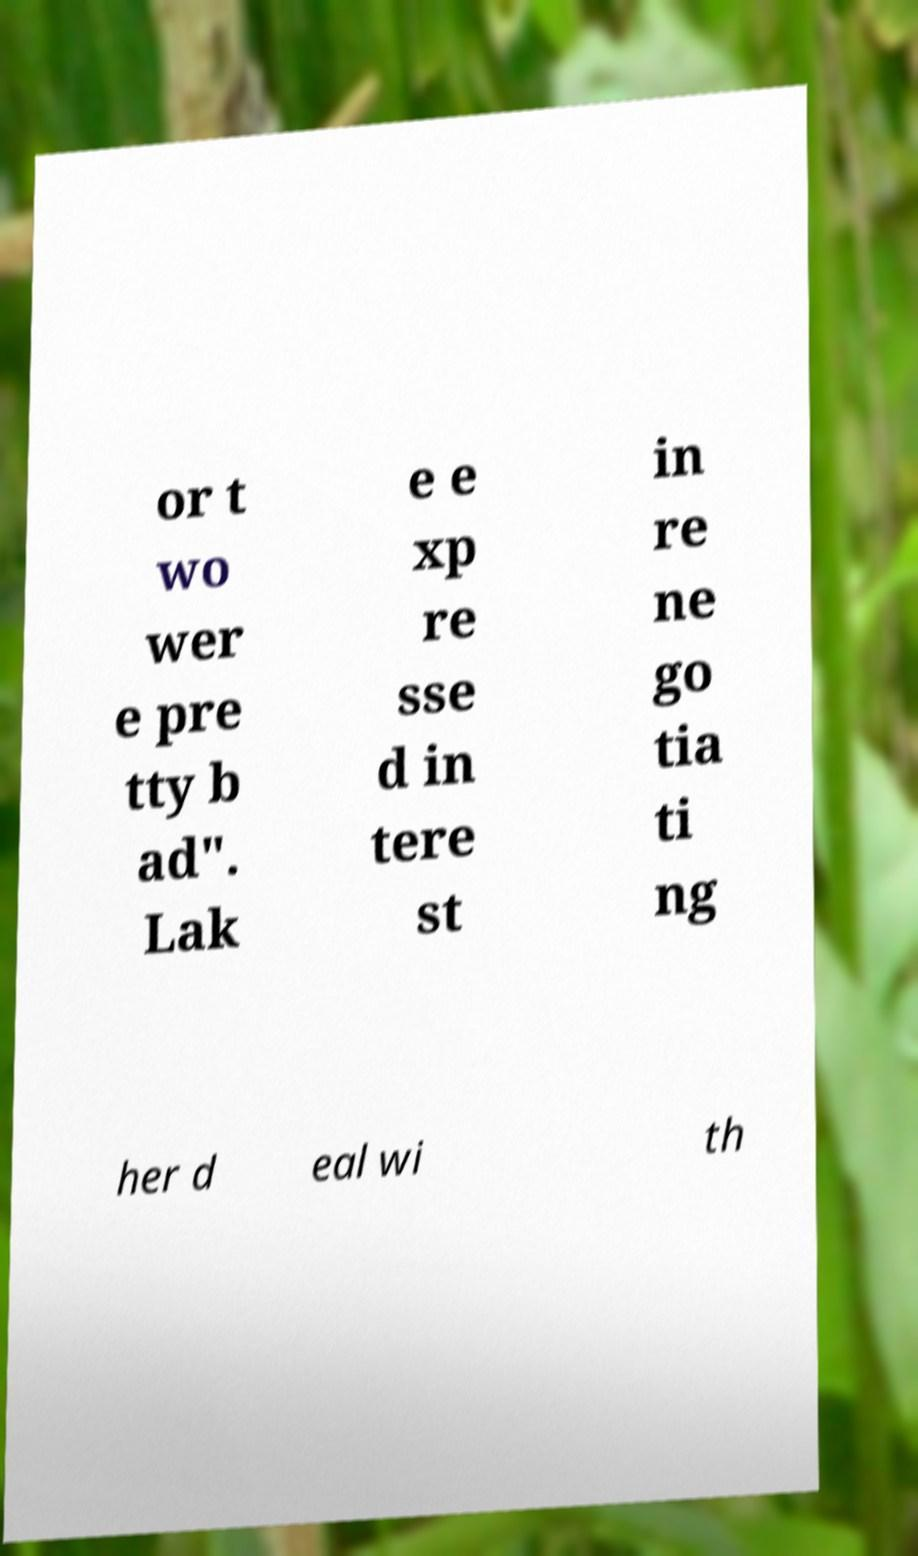Could you extract and type out the text from this image? or t wo wer e pre tty b ad". Lak e e xp re sse d in tere st in re ne go tia ti ng her d eal wi th 